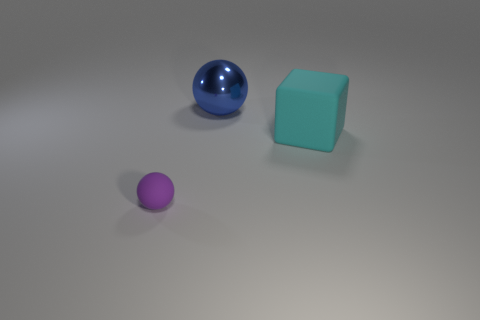Add 1 shiny things. How many objects exist? 4 Subtract all cubes. How many objects are left? 2 Add 2 gray shiny objects. How many gray shiny objects exist? 2 Subtract 1 purple balls. How many objects are left? 2 Subtract all big gray objects. Subtract all rubber cubes. How many objects are left? 2 Add 2 matte spheres. How many matte spheres are left? 3 